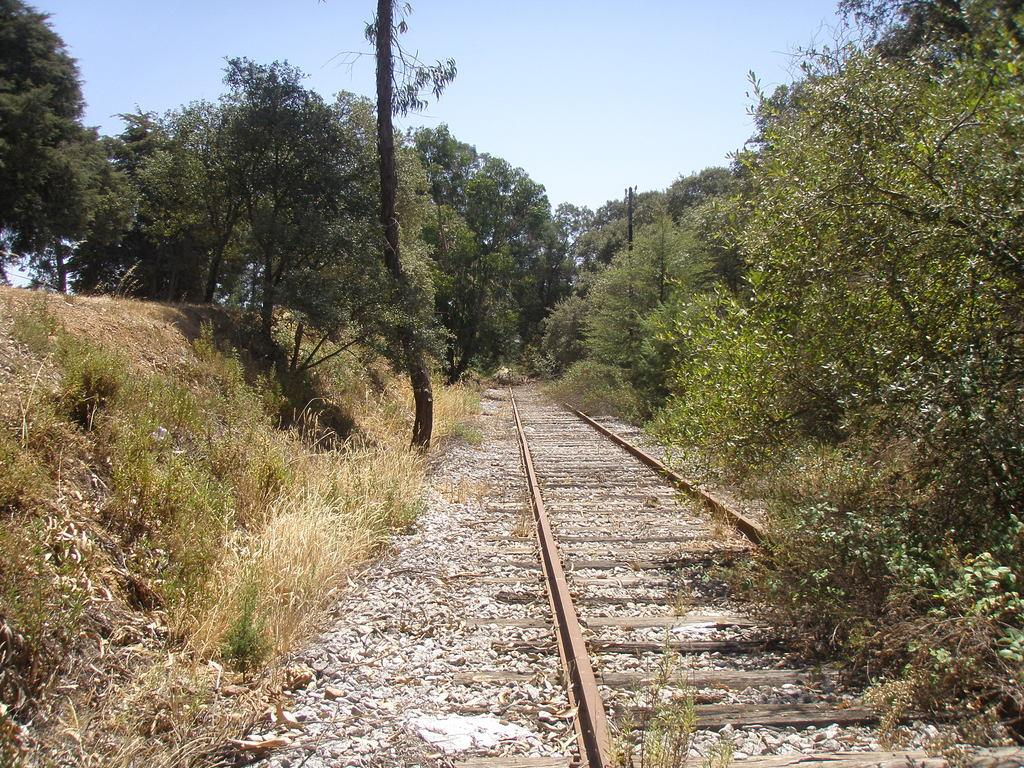What can be seen in the background of the image? The sky is visible in the background of the image. What type of transportation infrastructure is present in the image? There is a railway track in the image. What type of vegetation is present in the image? There are plants, grass, and trees in the image. What sound can be heard coming from the grass in the image? There is no sound coming from the grass in the image, as it is a still image and does not have any audible elements. 